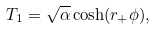Convert formula to latex. <formula><loc_0><loc_0><loc_500><loc_500>T _ { 1 } = \sqrt { \alpha } \cosh ( r _ { + } \phi ) ,</formula> 